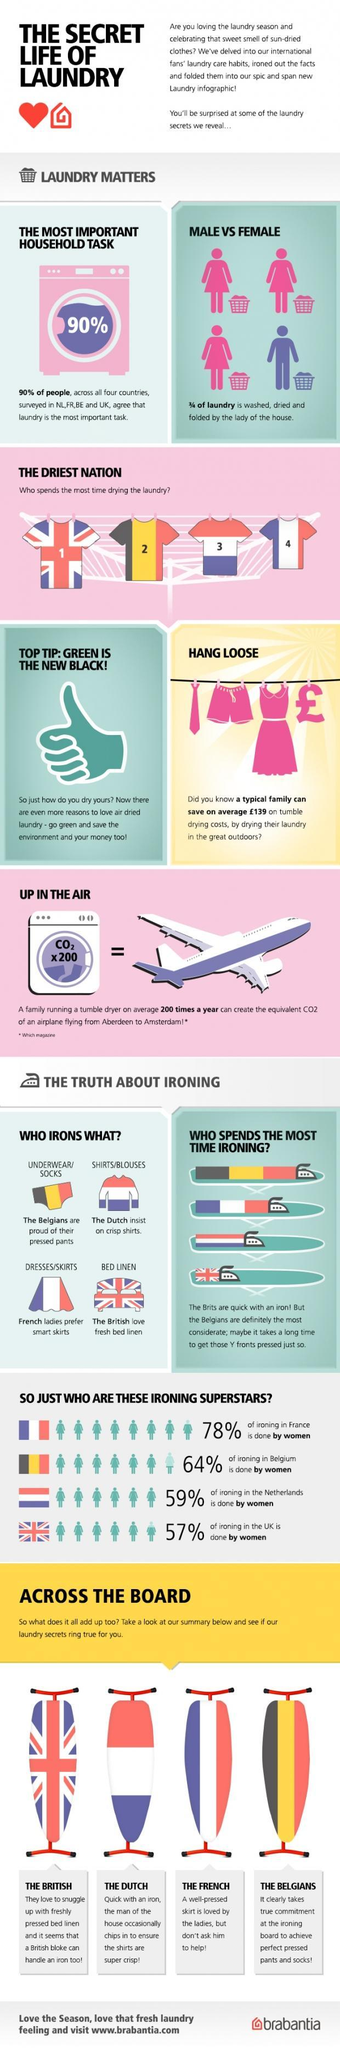What percentage of ironing is done by men in France ?
Answer the question with a short phrase. 22% What is the number of males doing laundry in a group of 4 people? 1 Who likes to wear neatly pressed shirts, Dutch, French, British, or Belgians? Dutch Who loves to wear neatly ironed skirts, Belgians, Dutch, French, or British ? French Which country is the driest nation, UK, Belgium, Netherlands, or France ? UK Which country spends the most time ironing UK, Belgium, Netherlands, or France ? Belgium Which country has the least percentage of women doing ironing  Belgium, UK, Netherlands, or France ? UK 